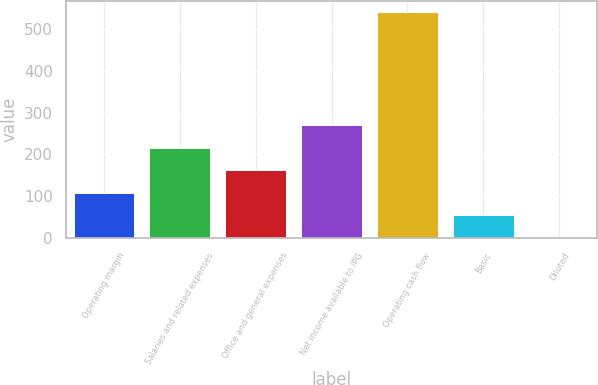Convert chart. <chart><loc_0><loc_0><loc_500><loc_500><bar_chart><fcel>Operating margin<fcel>Salaries and related expenses<fcel>Office and general expenses<fcel>Net income available to IPG<fcel>Operating cash flow<fcel>Basic<fcel>Diluted<nl><fcel>108.31<fcel>216.43<fcel>162.37<fcel>270.49<fcel>540.8<fcel>54.25<fcel>0.19<nl></chart> 